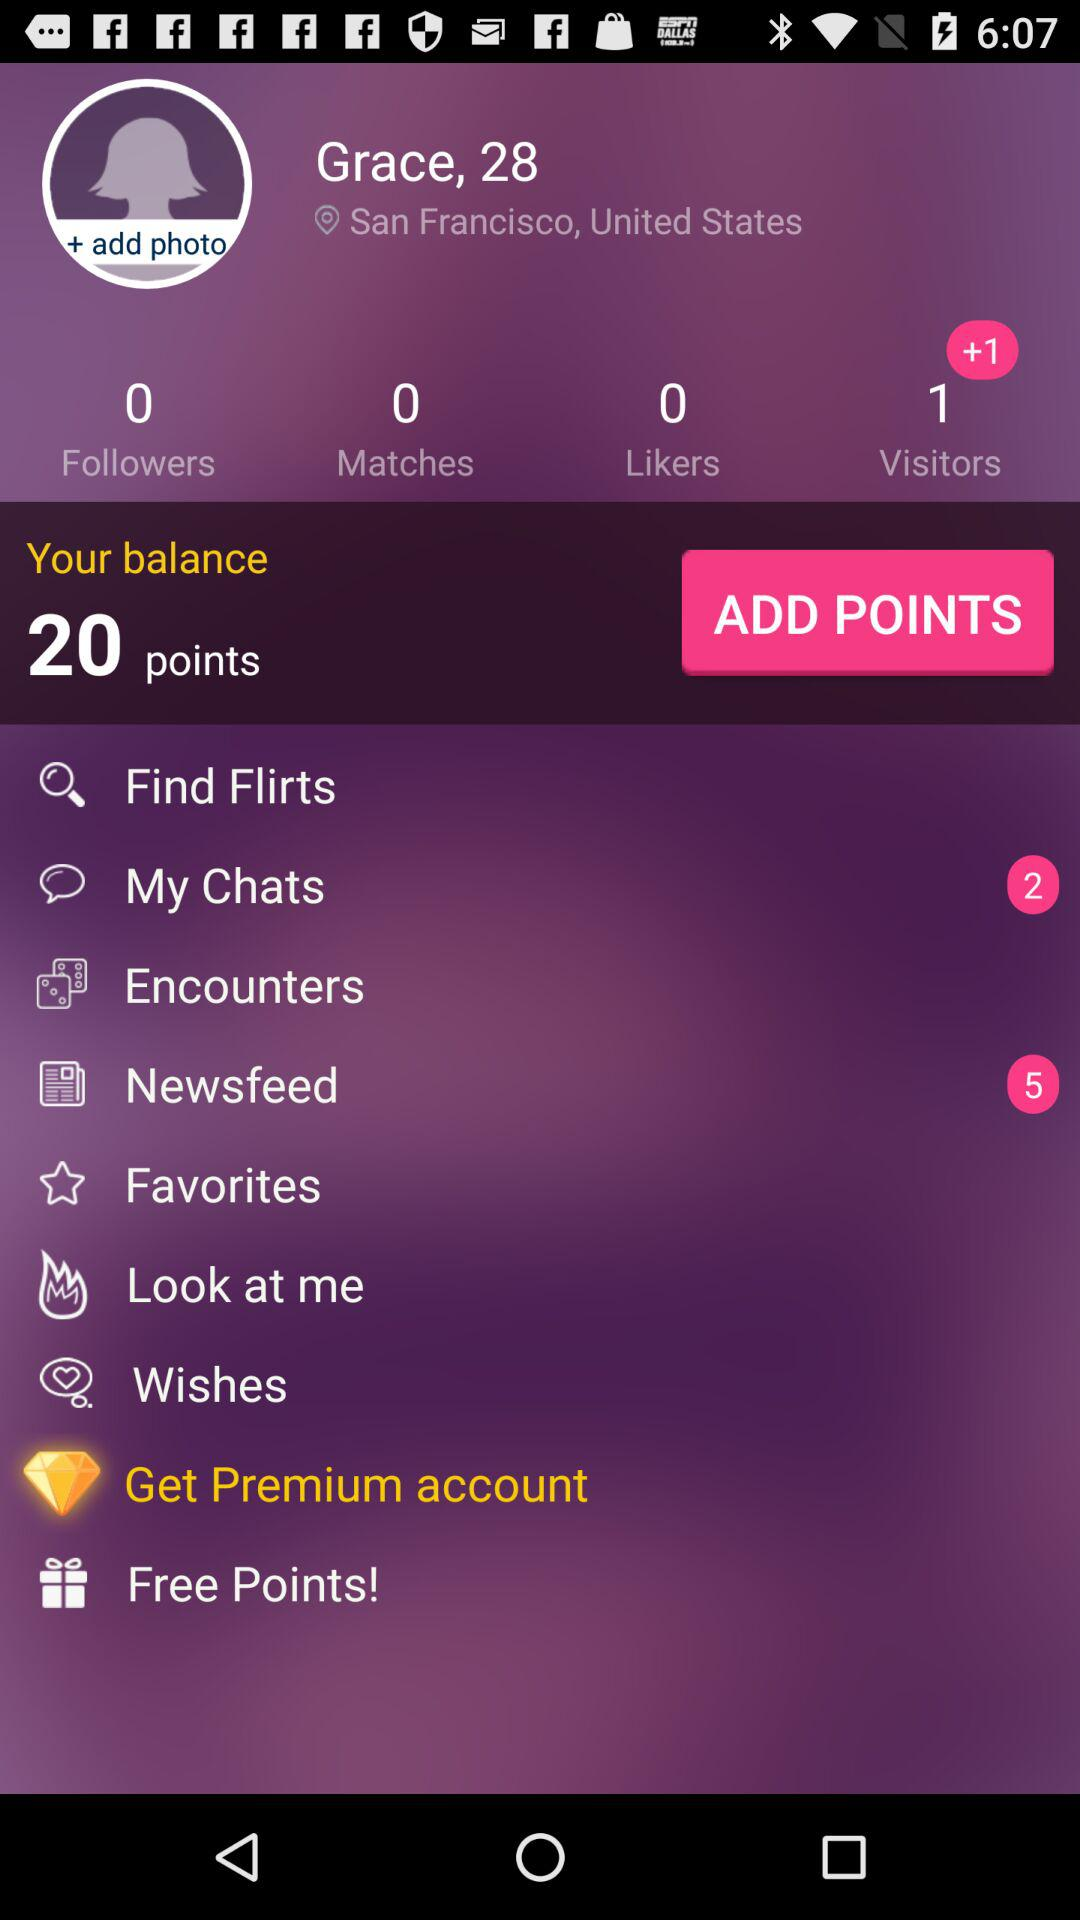When did the last chat take place?
When the provided information is insufficient, respond with <no answer>. <no answer> 